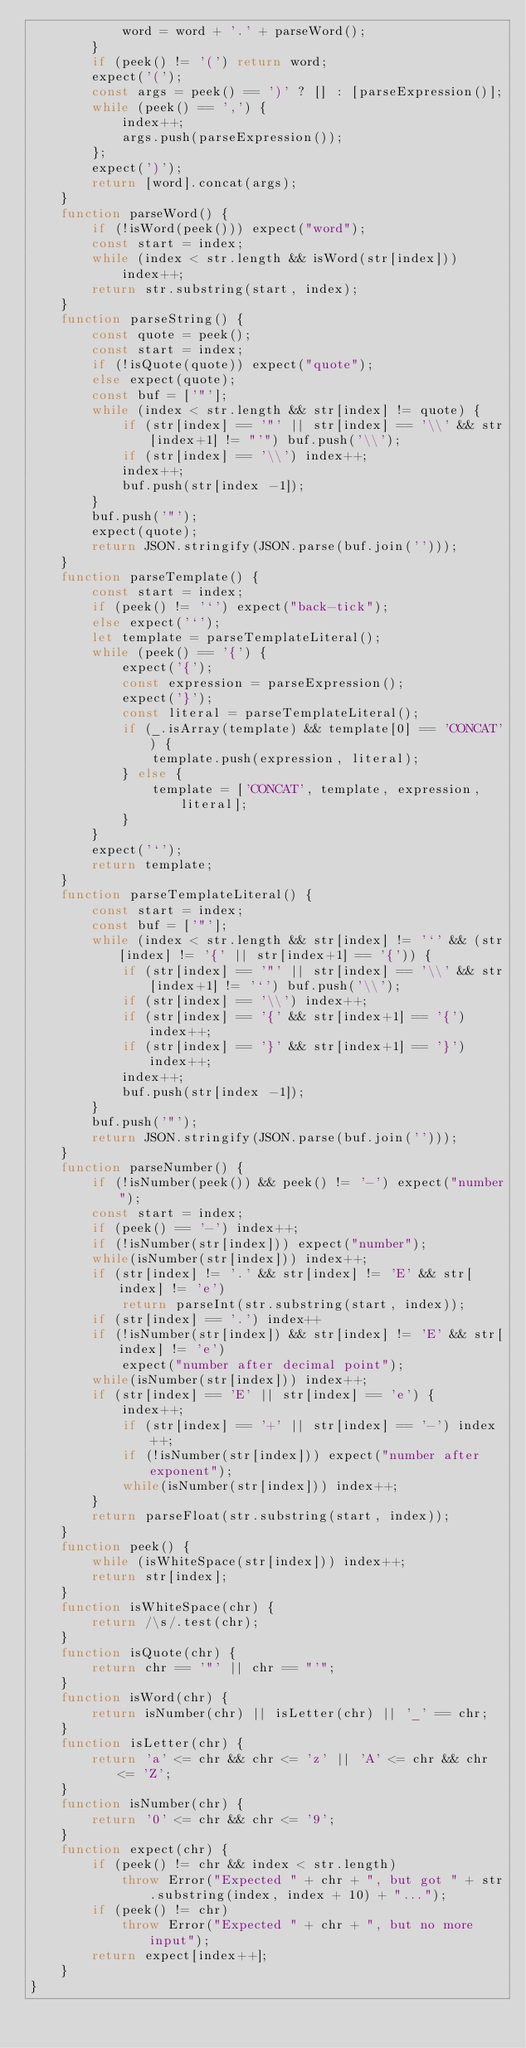Convert code to text. <code><loc_0><loc_0><loc_500><loc_500><_JavaScript_>            word = word + '.' + parseWord();
        }
        if (peek() != '(') return word;
        expect('(');
        const args = peek() == ')' ? [] : [parseExpression()];
        while (peek() == ',') {
            index++;
            args.push(parseExpression());
        };
        expect(')');
        return [word].concat(args);
    }
    function parseWord() {
        if (!isWord(peek())) expect("word");
        const start = index;
        while (index < str.length && isWord(str[index]))
            index++;
        return str.substring(start, index);
    }
    function parseString() {
        const quote = peek();
        const start = index;
        if (!isQuote(quote)) expect("quote");
        else expect(quote);
        const buf = ['"'];
        while (index < str.length && str[index] != quote) {
            if (str[index] == '"' || str[index] == '\\' && str[index+1] != "'") buf.push('\\');
            if (str[index] == '\\') index++;
            index++;
            buf.push(str[index -1]);
        }
        buf.push('"');
        expect(quote);
        return JSON.stringify(JSON.parse(buf.join('')));
    }
    function parseTemplate() {
        const start = index;
        if (peek() != '`') expect("back-tick");
        else expect('`');
        let template = parseTemplateLiteral();
        while (peek() == '{') {
            expect('{');
            const expression = parseExpression();
            expect('}');
            const literal = parseTemplateLiteral();
            if (_.isArray(template) && template[0] == 'CONCAT') {
                template.push(expression, literal);
            } else {
                template = ['CONCAT', template, expression, literal];
            }
        }
        expect('`');
        return template;
    }
    function parseTemplateLiteral() {
        const start = index;
        const buf = ['"'];
        while (index < str.length && str[index] != '`' && (str[index] != '{' || str[index+1] == '{')) {
            if (str[index] == '"' || str[index] == '\\' && str[index+1] != '`') buf.push('\\');
            if (str[index] == '\\') index++;
            if (str[index] == '{' && str[index+1] == '{') index++;
            if (str[index] == '}' && str[index+1] == '}') index++;
            index++;
            buf.push(str[index -1]);
        }
        buf.push('"');
        return JSON.stringify(JSON.parse(buf.join('')));
    }
    function parseNumber() {
        if (!isNumber(peek()) && peek() != '-') expect("number");
        const start = index;
        if (peek() == '-') index++;
        if (!isNumber(str[index])) expect("number");
        while(isNumber(str[index])) index++;
        if (str[index] != '.' && str[index] != 'E' && str[index] != 'e')
            return parseInt(str.substring(start, index));
        if (str[index] == '.') index++
        if (!isNumber(str[index]) && str[index] != 'E' && str[index] != 'e')
            expect("number after decimal point");
        while(isNumber(str[index])) index++;
        if (str[index] == 'E' || str[index] == 'e') {
            index++;
            if (str[index] == '+' || str[index] == '-') index++;
            if (!isNumber(str[index])) expect("number after exponent");
            while(isNumber(str[index])) index++;
        }
        return parseFloat(str.substring(start, index));
    }
    function peek() {
        while (isWhiteSpace(str[index])) index++;
        return str[index];
    }
    function isWhiteSpace(chr) {
        return /\s/.test(chr);
    }
    function isQuote(chr) {
        return chr == '"' || chr == "'";
    }
    function isWord(chr) {
        return isNumber(chr) || isLetter(chr) || '_' == chr;
    }
    function isLetter(chr) {
        return 'a' <= chr && chr <= 'z' || 'A' <= chr && chr <= 'Z';
    }
    function isNumber(chr) {
        return '0' <= chr && chr <= '9';
    }
    function expect(chr) {
        if (peek() != chr && index < str.length)
            throw Error("Expected " + chr + ", but got " + str.substring(index, index + 10) + "...");
        if (peek() != chr)
            throw Error("Expected " + chr + ", but no more input");
        return expect[index++];
    }
}
</code> 